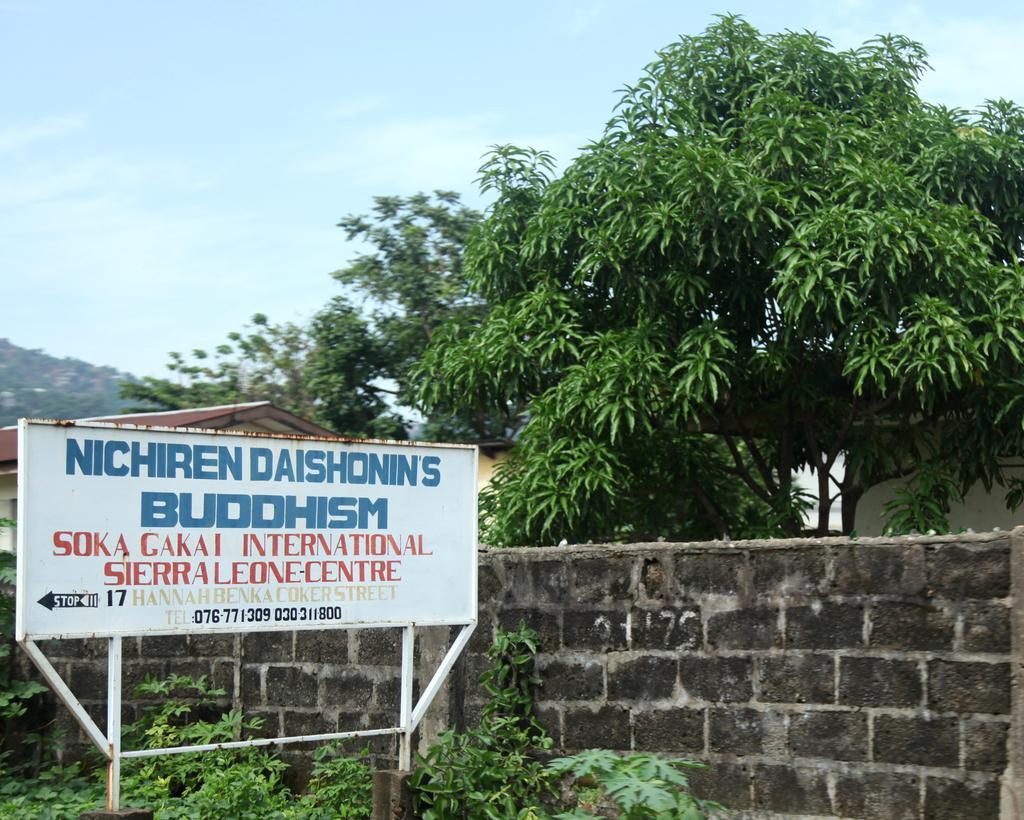How would you summarize this image in a sentence or two? In this image I can see the plants. I can also see the wall. On the left side I can see a board with some text written on it. In the background, I can see a house, the trees and clouds in the sky. 